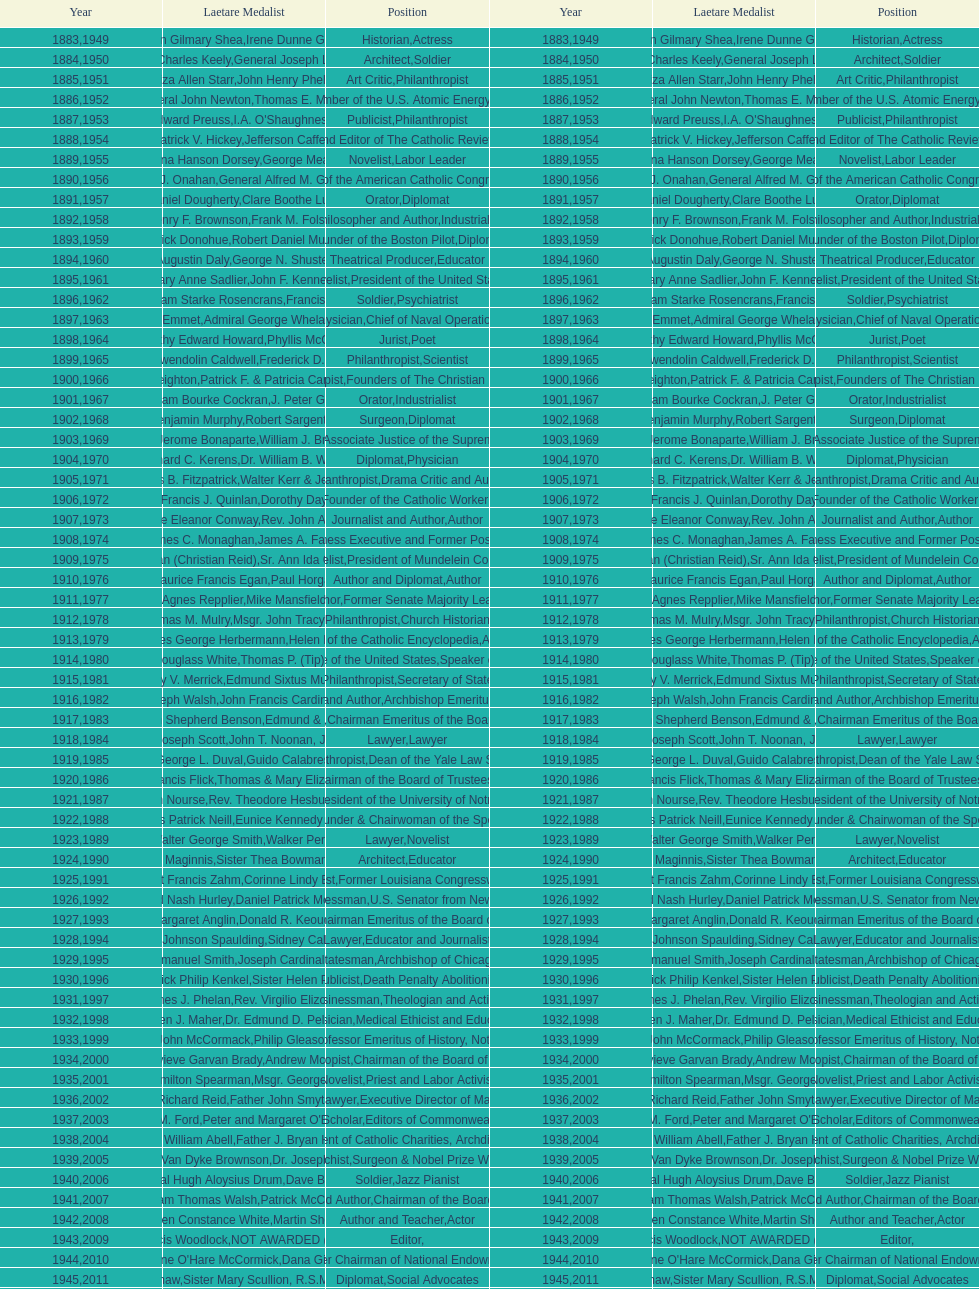On this chart, how many occurrences of "philanthropist" can be found in the position column? 9. 